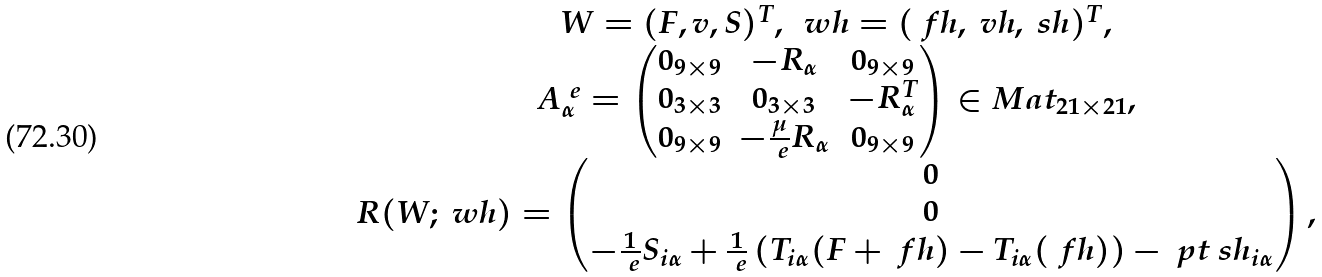<formula> <loc_0><loc_0><loc_500><loc_500>\begin{array} { c } W = ( F , v , S ) ^ { T } , \ \ w h = ( \ f h , \ v h , \ s h ) ^ { T } , \\ A ^ { \ e } _ { \alpha } = \begin{pmatrix} 0 _ { 9 \times 9 } & - R _ { \alpha } & 0 _ { 9 \times 9 } \\ 0 _ { 3 \times 3 } & 0 _ { 3 \times 3 } & - R _ { \alpha } ^ { T } \\ 0 _ { 9 \times 9 } & - \frac { \mu } { \ e } R _ { \alpha } & 0 _ { 9 \times 9 } \end{pmatrix} \in M a t _ { 2 1 \times 2 1 } , \\ R ( W ; \ w h ) = \begin{pmatrix} 0 \\ 0 \\ - \frac { 1 } { \ e } S _ { i \alpha } + \frac { 1 } { \ e } \left ( T _ { i \alpha } ( F + \ f h ) - T _ { i \alpha } ( \ f h ) \right ) - \ p t \ s h _ { i \alpha } \end{pmatrix} , \end{array}</formula> 